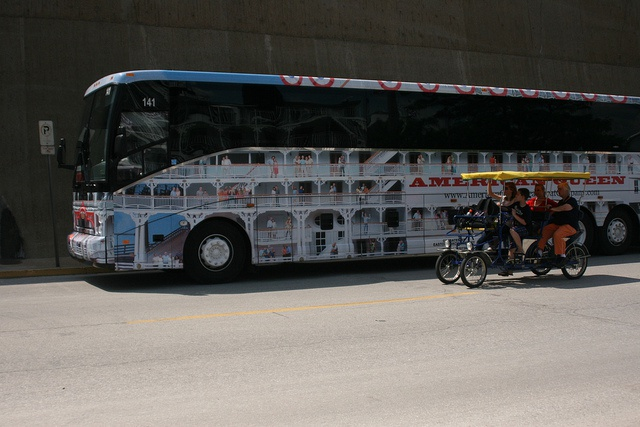Describe the objects in this image and their specific colors. I can see bus in black, gray, and blue tones, bicycle in black, gray, maroon, and olive tones, people in black, maroon, gray, and darkblue tones, people in black, maroon, and gray tones, and people in black, maroon, and gray tones in this image. 